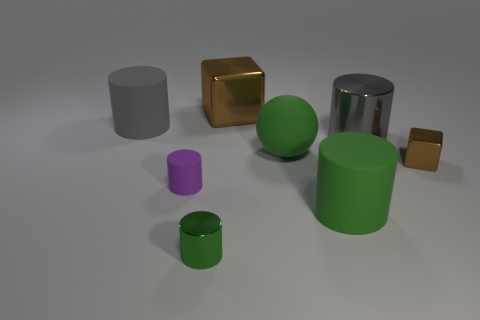Subtract all large metal cylinders. How many cylinders are left? 4 Subtract all purple cylinders. How many cylinders are left? 4 Subtract 3 cylinders. How many cylinders are left? 2 Add 1 green shiny things. How many objects exist? 9 Subtract 2 green cylinders. How many objects are left? 6 Subtract all cylinders. How many objects are left? 3 Subtract all gray cylinders. Subtract all gray blocks. How many cylinders are left? 3 Subtract all purple cubes. How many blue cylinders are left? 0 Subtract all tiny rubber cylinders. Subtract all small brown shiny blocks. How many objects are left? 6 Add 6 green matte objects. How many green matte objects are left? 8 